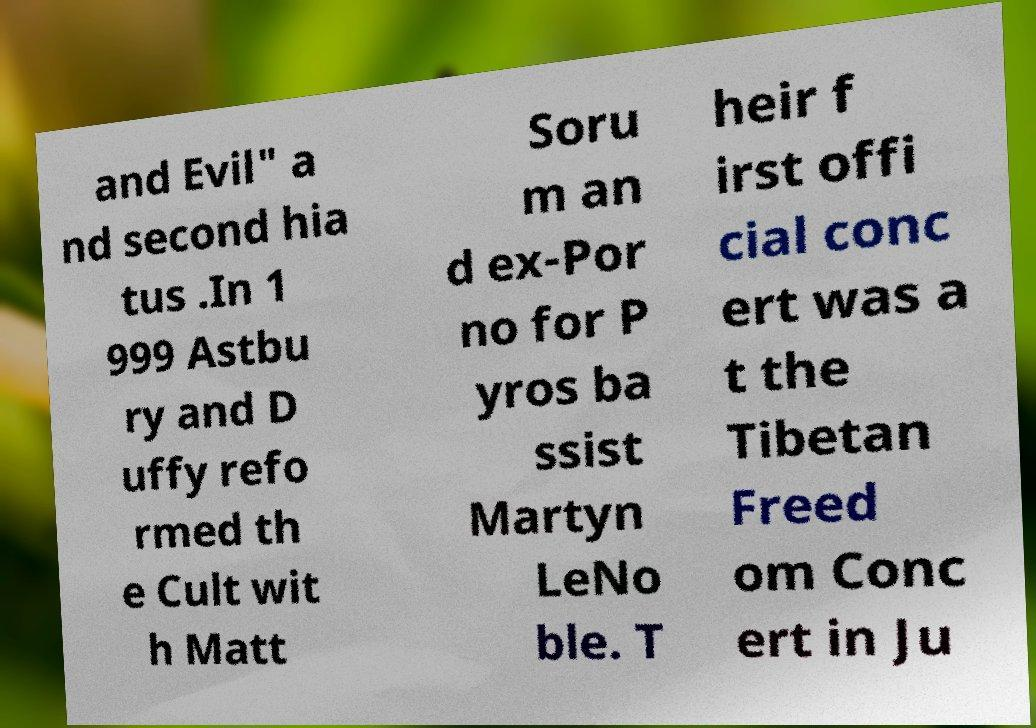Can you read and provide the text displayed in the image?This photo seems to have some interesting text. Can you extract and type it out for me? and Evil" a nd second hia tus .In 1 999 Astbu ry and D uffy refo rmed th e Cult wit h Matt Soru m an d ex-Por no for P yros ba ssist Martyn LeNo ble. T heir f irst offi cial conc ert was a t the Tibetan Freed om Conc ert in Ju 